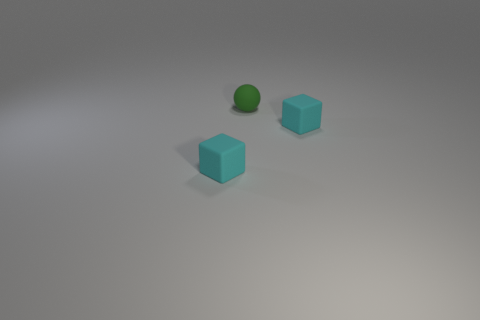Add 3 small cyan rubber things. How many objects exist? 6 Subtract all cubes. How many objects are left? 1 Subtract all small cubes. Subtract all small green spheres. How many objects are left? 0 Add 3 green rubber objects. How many green rubber objects are left? 4 Add 2 rubber objects. How many rubber objects exist? 5 Subtract 0 purple cylinders. How many objects are left? 3 